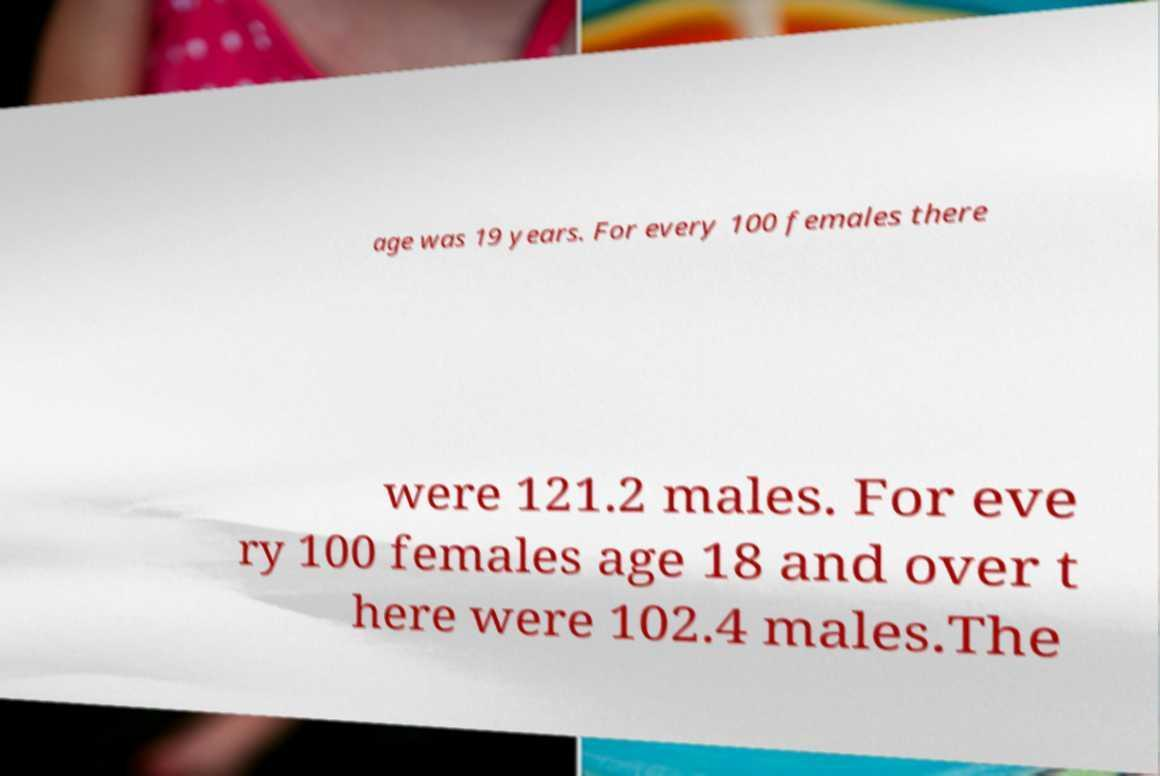For documentation purposes, I need the text within this image transcribed. Could you provide that? age was 19 years. For every 100 females there were 121.2 males. For eve ry 100 females age 18 and over t here were 102.4 males.The 